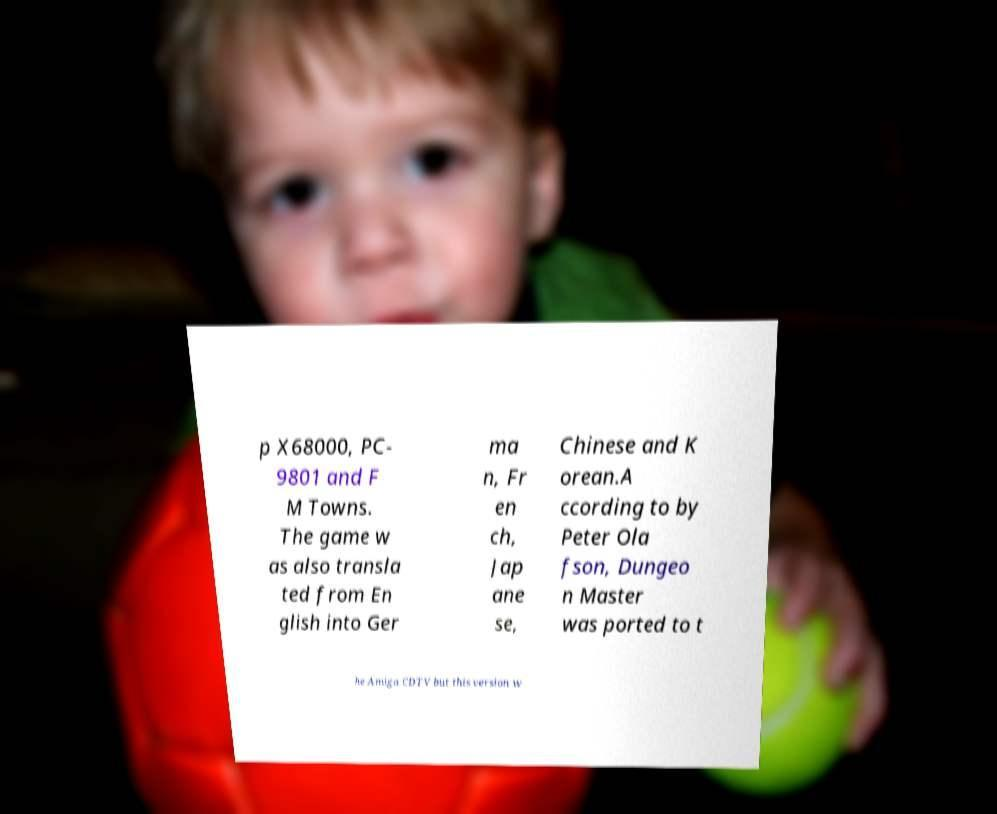Can you read and provide the text displayed in the image?This photo seems to have some interesting text. Can you extract and type it out for me? p X68000, PC- 9801 and F M Towns. The game w as also transla ted from En glish into Ger ma n, Fr en ch, Jap ane se, Chinese and K orean.A ccording to by Peter Ola fson, Dungeo n Master was ported to t he Amiga CDTV but this version w 